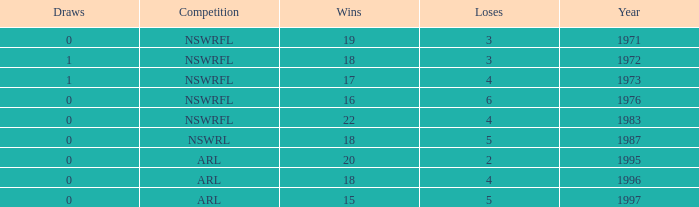What average Loses has Draws less than 0? None. 